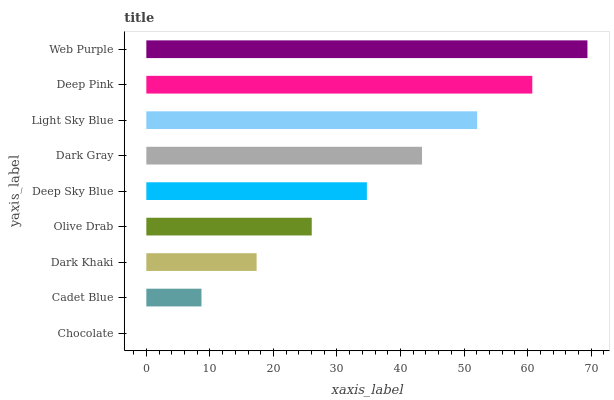Is Chocolate the minimum?
Answer yes or no. Yes. Is Web Purple the maximum?
Answer yes or no. Yes. Is Cadet Blue the minimum?
Answer yes or no. No. Is Cadet Blue the maximum?
Answer yes or no. No. Is Cadet Blue greater than Chocolate?
Answer yes or no. Yes. Is Chocolate less than Cadet Blue?
Answer yes or no. Yes. Is Chocolate greater than Cadet Blue?
Answer yes or no. No. Is Cadet Blue less than Chocolate?
Answer yes or no. No. Is Deep Sky Blue the high median?
Answer yes or no. Yes. Is Deep Sky Blue the low median?
Answer yes or no. Yes. Is Dark Khaki the high median?
Answer yes or no. No. Is Olive Drab the low median?
Answer yes or no. No. 